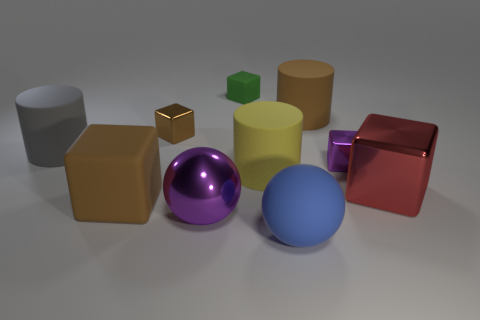There is a tiny cube that is the same color as the large matte cube; what is it made of?
Offer a terse response. Metal. What number of other things are there of the same color as the matte sphere?
Make the answer very short. 0. Is the color of the large shiny sphere the same as the tiny metal cube that is on the left side of the large yellow object?
Offer a terse response. No. There is a large metallic thing that is the same shape as the small purple thing; what color is it?
Your answer should be compact. Red. Does the gray cylinder have the same material as the cube on the left side of the small brown metal thing?
Ensure brevity in your answer.  Yes. What color is the large matte cube?
Give a very brief answer. Brown. There is a matte thing that is in front of the brown thing that is in front of the purple shiny thing to the right of the purple sphere; what is its color?
Provide a short and direct response. Blue. Do the blue thing and the large shiny object that is behind the large purple sphere have the same shape?
Offer a very short reply. No. What color is the matte object that is to the left of the blue sphere and in front of the yellow rubber thing?
Keep it short and to the point. Brown. Is there a big purple rubber thing that has the same shape as the large gray thing?
Give a very brief answer. No. 